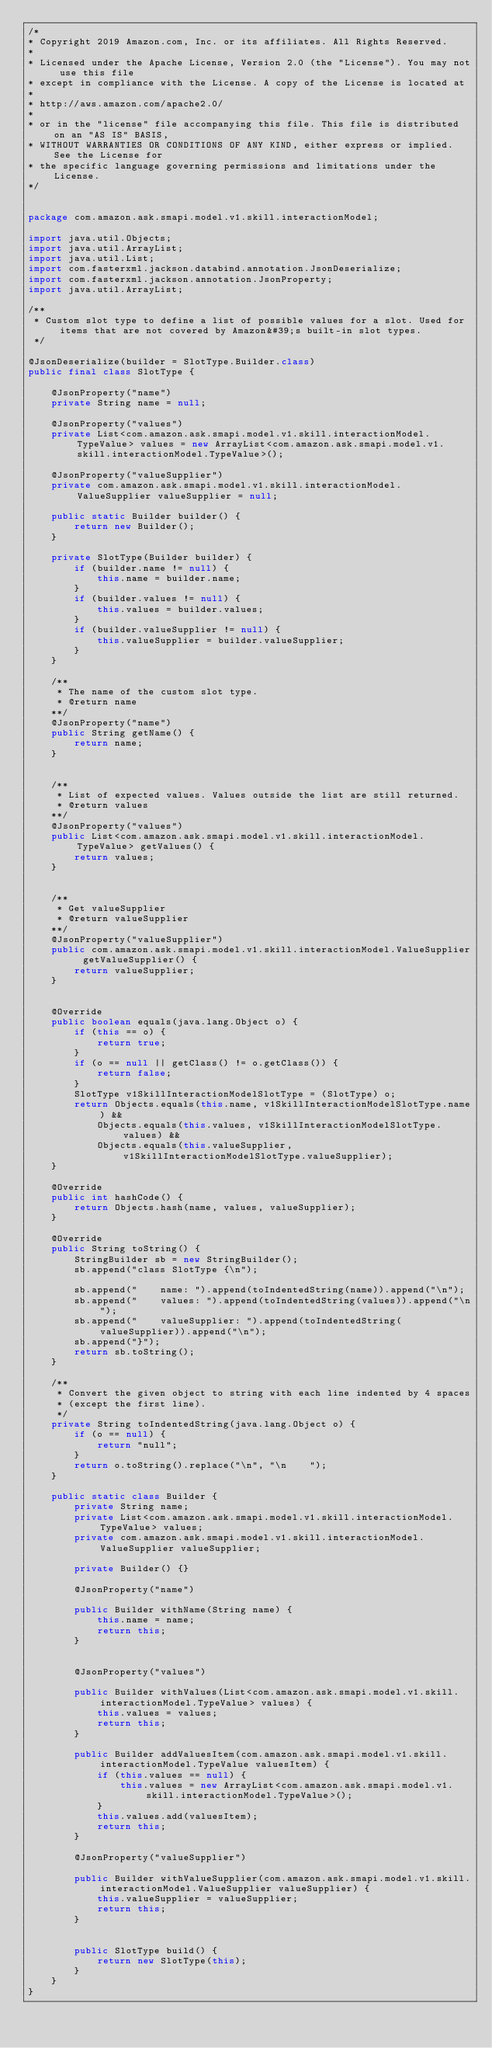Convert code to text. <code><loc_0><loc_0><loc_500><loc_500><_Java_>/*
* Copyright 2019 Amazon.com, Inc. or its affiliates. All Rights Reserved.
*
* Licensed under the Apache License, Version 2.0 (the "License"). You may not use this file
* except in compliance with the License. A copy of the License is located at
*
* http://aws.amazon.com/apache2.0/
*
* or in the "license" file accompanying this file. This file is distributed on an "AS IS" BASIS,
* WITHOUT WARRANTIES OR CONDITIONS OF ANY KIND, either express or implied. See the License for
* the specific language governing permissions and limitations under the License.
*/


package com.amazon.ask.smapi.model.v1.skill.interactionModel;

import java.util.Objects;
import java.util.ArrayList;
import java.util.List;
import com.fasterxml.jackson.databind.annotation.JsonDeserialize;
import com.fasterxml.jackson.annotation.JsonProperty;
import java.util.ArrayList;

/**
 * Custom slot type to define a list of possible values for a slot. Used for items that are not covered by Amazon&#39;s built-in slot types.
 */

@JsonDeserialize(builder = SlotType.Builder.class)
public final class SlotType {

    @JsonProperty("name")
    private String name = null;

    @JsonProperty("values")
    private List<com.amazon.ask.smapi.model.v1.skill.interactionModel.TypeValue> values = new ArrayList<com.amazon.ask.smapi.model.v1.skill.interactionModel.TypeValue>();

    @JsonProperty("valueSupplier")
    private com.amazon.ask.smapi.model.v1.skill.interactionModel.ValueSupplier valueSupplier = null;

    public static Builder builder() {
        return new Builder();
    }

    private SlotType(Builder builder) {
        if (builder.name != null) {
            this.name = builder.name;
        }
        if (builder.values != null) {
            this.values = builder.values;
        }
        if (builder.valueSupplier != null) {
            this.valueSupplier = builder.valueSupplier;
        }
    }

    /**
     * The name of the custom slot type.
     * @return name
    **/
    @JsonProperty("name")
    public String getName() {
        return name;
    }


    /**
     * List of expected values. Values outside the list are still returned.
     * @return values
    **/
    @JsonProperty("values")
    public List<com.amazon.ask.smapi.model.v1.skill.interactionModel.TypeValue> getValues() {
        return values;
    }


    /**
     * Get valueSupplier
     * @return valueSupplier
    **/
    @JsonProperty("valueSupplier")
    public com.amazon.ask.smapi.model.v1.skill.interactionModel.ValueSupplier getValueSupplier() {
        return valueSupplier;
    }


    @Override
    public boolean equals(java.lang.Object o) {
        if (this == o) {
            return true;
        }
        if (o == null || getClass() != o.getClass()) {
            return false;
        }
        SlotType v1SkillInteractionModelSlotType = (SlotType) o;
        return Objects.equals(this.name, v1SkillInteractionModelSlotType.name) &&
            Objects.equals(this.values, v1SkillInteractionModelSlotType.values) &&
            Objects.equals(this.valueSupplier, v1SkillInteractionModelSlotType.valueSupplier);
    }

    @Override
    public int hashCode() {
        return Objects.hash(name, values, valueSupplier);
    }

    @Override
    public String toString() {
        StringBuilder sb = new StringBuilder();
        sb.append("class SlotType {\n");
        
        sb.append("    name: ").append(toIndentedString(name)).append("\n");
        sb.append("    values: ").append(toIndentedString(values)).append("\n");
        sb.append("    valueSupplier: ").append(toIndentedString(valueSupplier)).append("\n");
        sb.append("}");
        return sb.toString();
    }

    /**
     * Convert the given object to string with each line indented by 4 spaces
     * (except the first line).
     */
    private String toIndentedString(java.lang.Object o) {
        if (o == null) {
            return "null";
        }
        return o.toString().replace("\n", "\n    ");
    }
  
    public static class Builder {
        private String name;
        private List<com.amazon.ask.smapi.model.v1.skill.interactionModel.TypeValue> values;
        private com.amazon.ask.smapi.model.v1.skill.interactionModel.ValueSupplier valueSupplier;

        private Builder() {}

        @JsonProperty("name")

        public Builder withName(String name) {
            this.name = name;
            return this;
        }


        @JsonProperty("values")

        public Builder withValues(List<com.amazon.ask.smapi.model.v1.skill.interactionModel.TypeValue> values) {
            this.values = values;
            return this;
        }

        public Builder addValuesItem(com.amazon.ask.smapi.model.v1.skill.interactionModel.TypeValue valuesItem) {
            if (this.values == null) {
                this.values = new ArrayList<com.amazon.ask.smapi.model.v1.skill.interactionModel.TypeValue>();
            }
            this.values.add(valuesItem);
            return this;
        }

        @JsonProperty("valueSupplier")

        public Builder withValueSupplier(com.amazon.ask.smapi.model.v1.skill.interactionModel.ValueSupplier valueSupplier) {
            this.valueSupplier = valueSupplier;
            return this;
        }


        public SlotType build() {
            return new SlotType(this);
        }
    }
}

</code> 